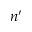<formula> <loc_0><loc_0><loc_500><loc_500>n ^ { \prime }</formula> 